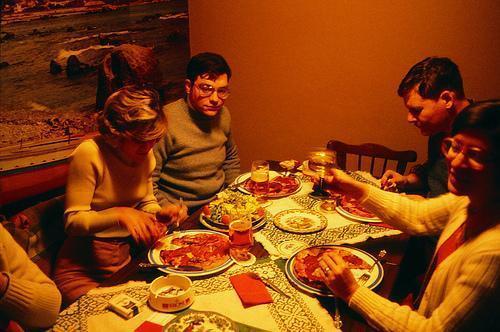How many people have glasses on?
Give a very brief answer. 2. 